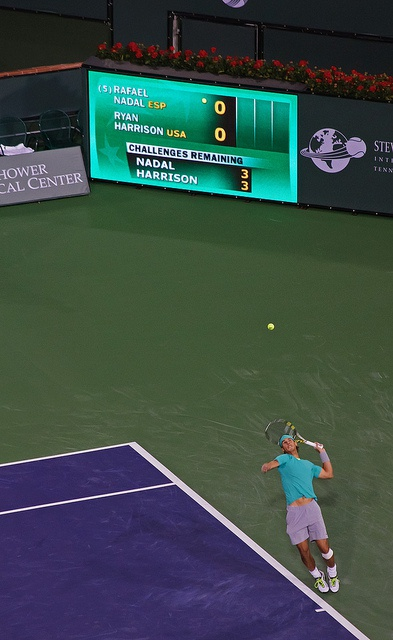Describe the objects in this image and their specific colors. I can see tv in black, teal, and turquoise tones, people in black, teal, gray, and brown tones, potted plant in black and maroon tones, chair in black, darkblue, and gray tones, and chair in black, darkgray, lavender, and gray tones in this image. 